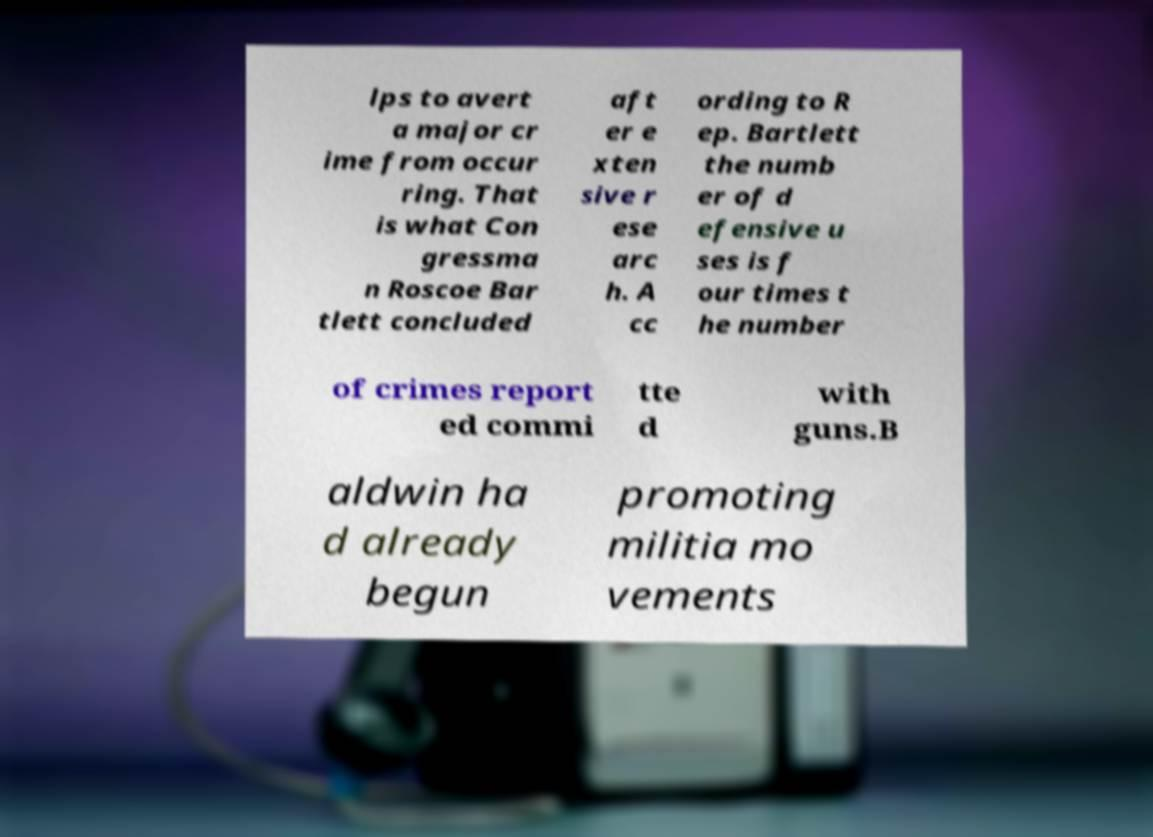There's text embedded in this image that I need extracted. Can you transcribe it verbatim? lps to avert a major cr ime from occur ring. That is what Con gressma n Roscoe Bar tlett concluded aft er e xten sive r ese arc h. A cc ording to R ep. Bartlett the numb er of d efensive u ses is f our times t he number of crimes report ed commi tte d with guns.B aldwin ha d already begun promoting militia mo vements 